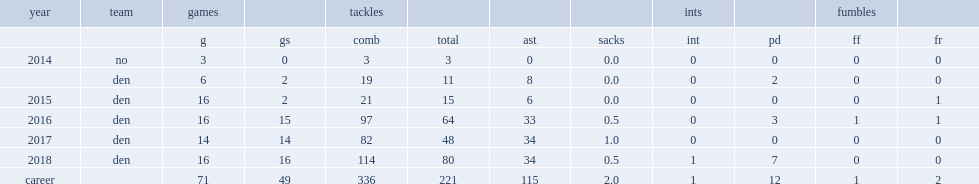How many combined tackles did todd davis get in 2018? 114.0. 